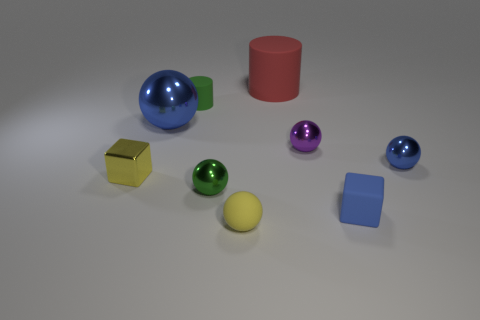Subtract all big blue spheres. How many spheres are left? 4 Subtract all brown cylinders. How many blue balls are left? 2 Add 1 tiny purple rubber cubes. How many objects exist? 10 Subtract all green balls. How many balls are left? 4 Subtract all blocks. How many objects are left? 7 Subtract 3 balls. How many balls are left? 2 Subtract all blue cylinders. Subtract all gray spheres. How many cylinders are left? 2 Subtract all cyan balls. Subtract all red cylinders. How many objects are left? 8 Add 6 big red things. How many big red things are left? 7 Add 7 yellow balls. How many yellow balls exist? 8 